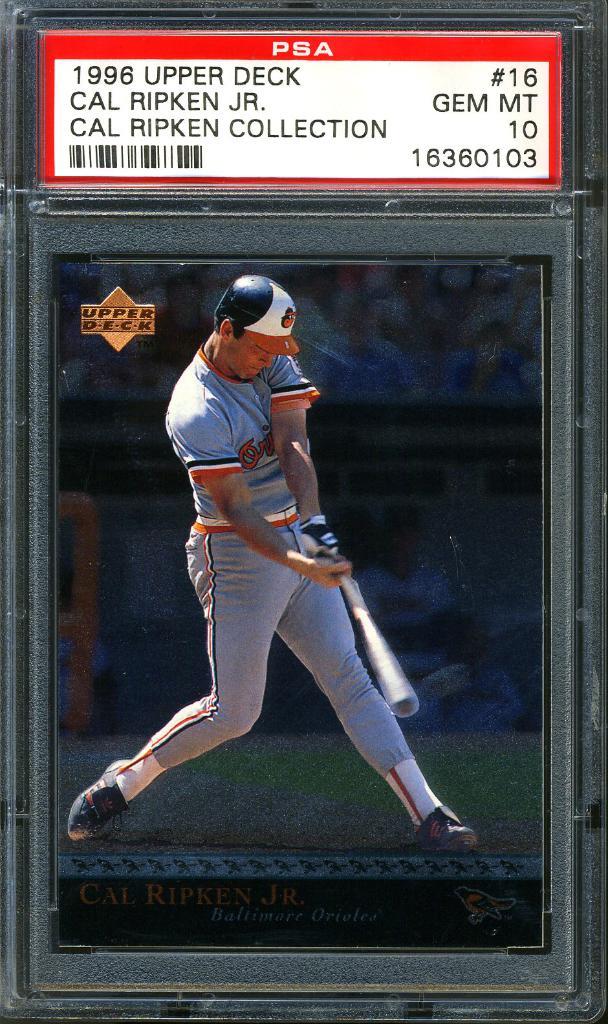What year is the baseball card?
Provide a succinct answer. 1996. Who is the player on the card?
Offer a terse response. Cal ripken jr. 